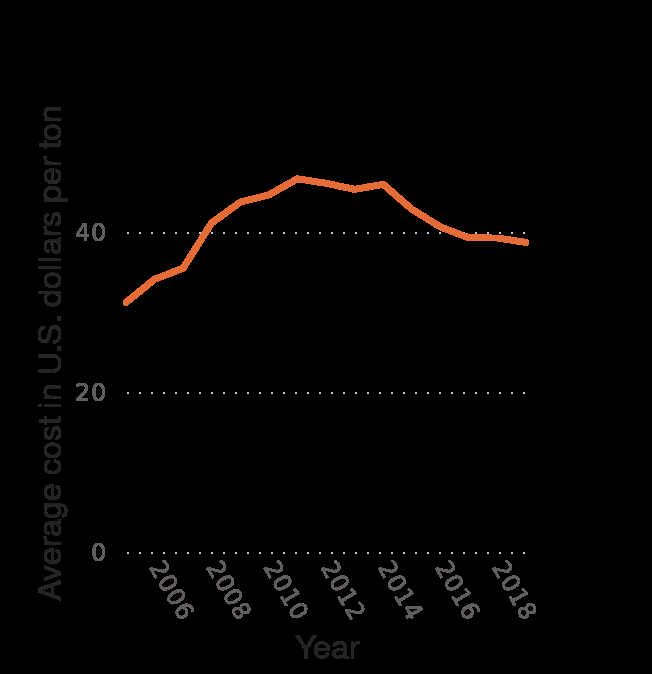<image>
What is the overall time frame covered by the line graph? The overall time frame covered by the line graph is from 2005 to 2019. What was the highest cost per tonne in 2011?  The highest cost per tonne in 2011 was around $50. What is the increment value on the x-axis?  The increment value on the x-axis is 2 years. Offer a thorough analysis of the image. The years on the x axis go up by increments of 2. The cost in dollars per tonne on the y axis go up by increments of 20. The linear graph peaks in 2011 at its highest cost of around $50 per tonne. please describe the details of the chart Average cost of coal for the electric power industry in the U.S. from 2005 to 2019 (in U.S. dollars per ton) is a line graph. A linear scale from 2006 to 2018 can be found on the x-axis, marked Year. On the y-axis, Average cost in U.S. dollars per ton is measured. 